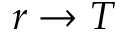Convert formula to latex. <formula><loc_0><loc_0><loc_500><loc_500>r \to T</formula> 